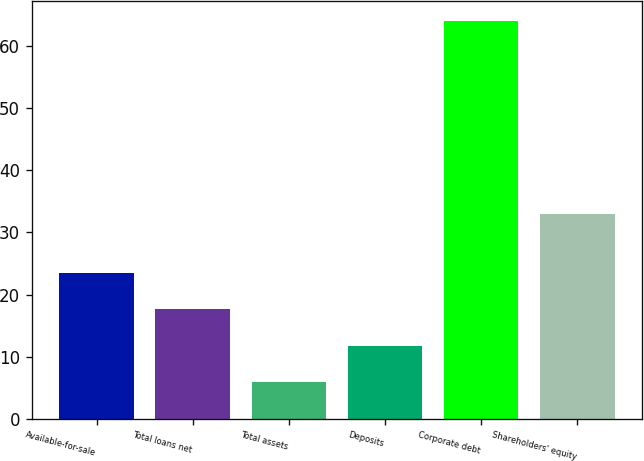<chart> <loc_0><loc_0><loc_500><loc_500><bar_chart><fcel>Available-for-sale<fcel>Total loans net<fcel>Total assets<fcel>Deposits<fcel>Corporate debt<fcel>Shareholders' equity<nl><fcel>23.4<fcel>17.6<fcel>6<fcel>11.8<fcel>64<fcel>33<nl></chart> 